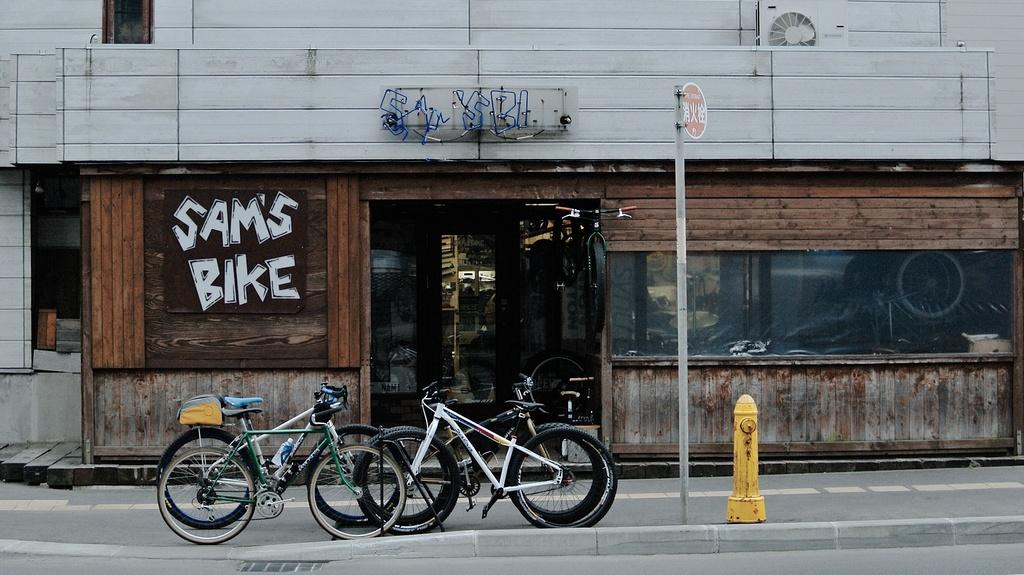What type of establishment is depicted in the image? There is a store in the image. What can be seen in front of the store? There are cycles and a pole in front of the store. Is there any safety equipment visible in the image? Yes, there is a fire extinguisher in front of the store. What type of river is flowing near the store in the image? There is no river present in the image; it only shows a store, cycles, a pole, and a fire extinguisher. 